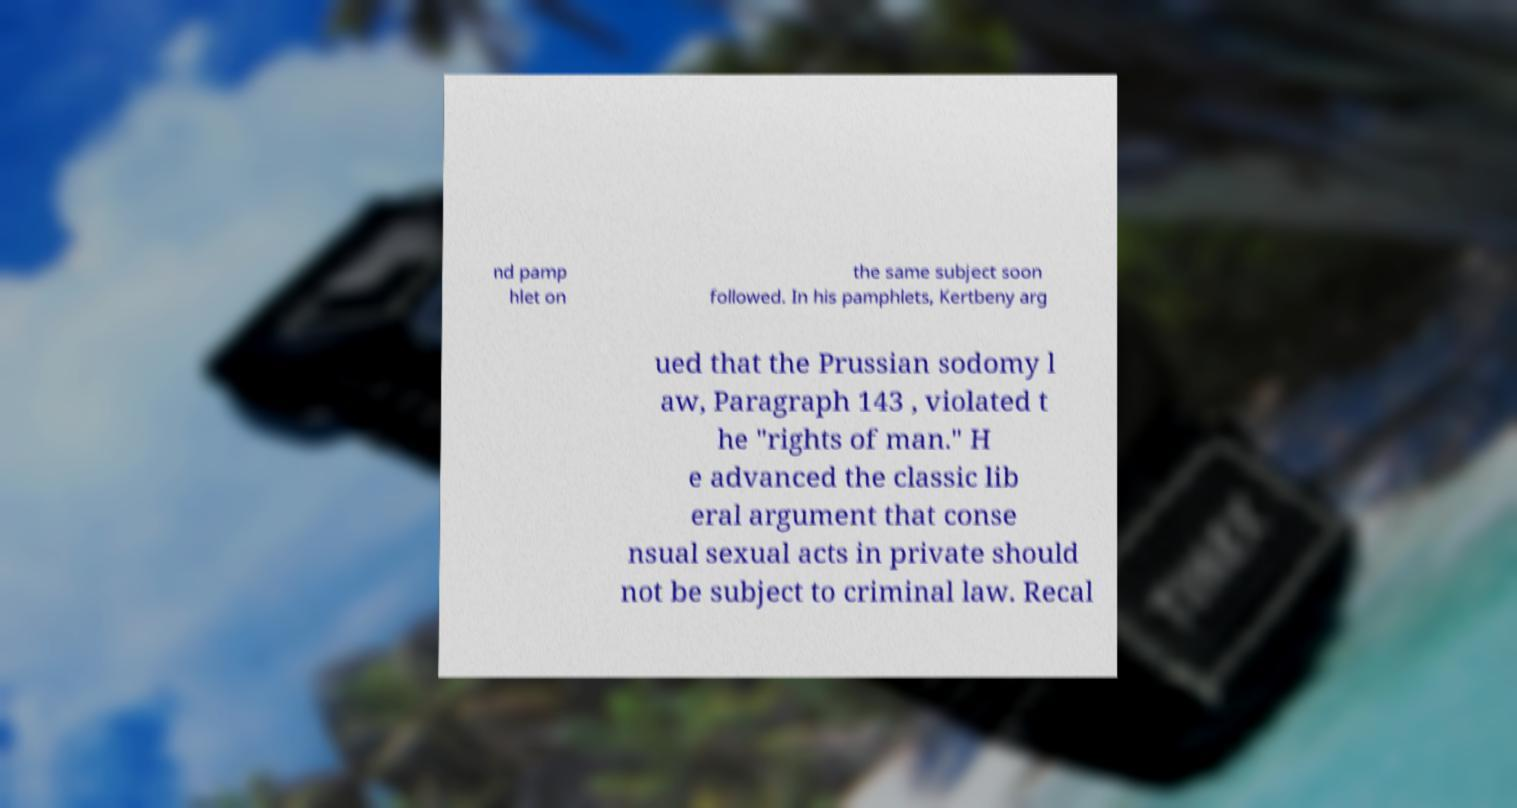I need the written content from this picture converted into text. Can you do that? nd pamp hlet on the same subject soon followed. In his pamphlets, Kertbeny arg ued that the Prussian sodomy l aw, Paragraph 143 , violated t he "rights of man." H e advanced the classic lib eral argument that conse nsual sexual acts in private should not be subject to criminal law. Recal 